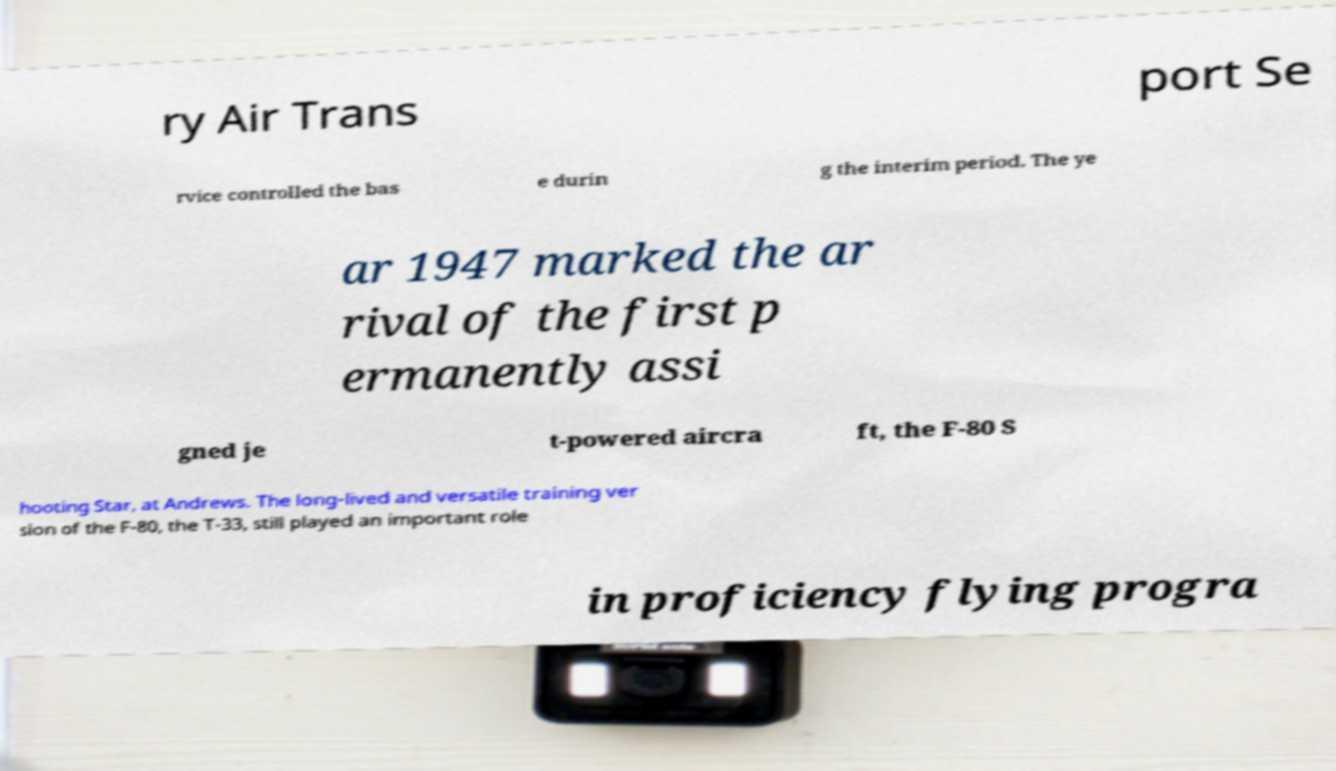Can you accurately transcribe the text from the provided image for me? ry Air Trans port Se rvice controlled the bas e durin g the interim period. The ye ar 1947 marked the ar rival of the first p ermanently assi gned je t-powered aircra ft, the F-80 S hooting Star, at Andrews. The long-lived and versatile training ver sion of the F-80, the T-33, still played an important role in proficiency flying progra 